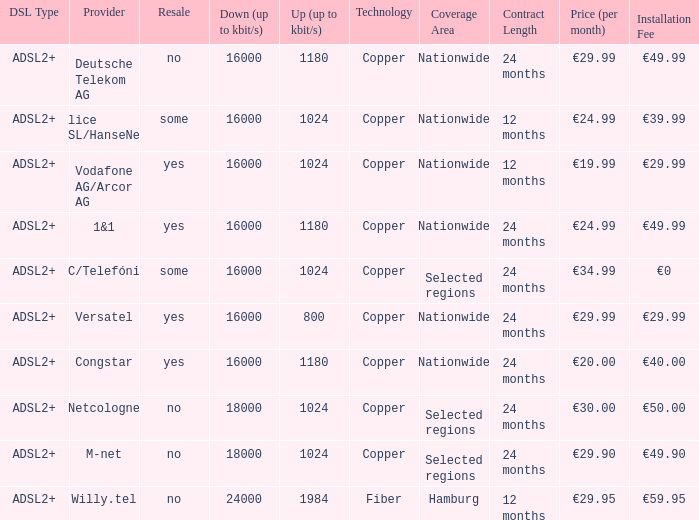What is the resale category for the provider NetCologne? No. 